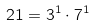Convert formula to latex. <formula><loc_0><loc_0><loc_500><loc_500>2 1 = 3 ^ { 1 } \cdot 7 ^ { 1 }</formula> 